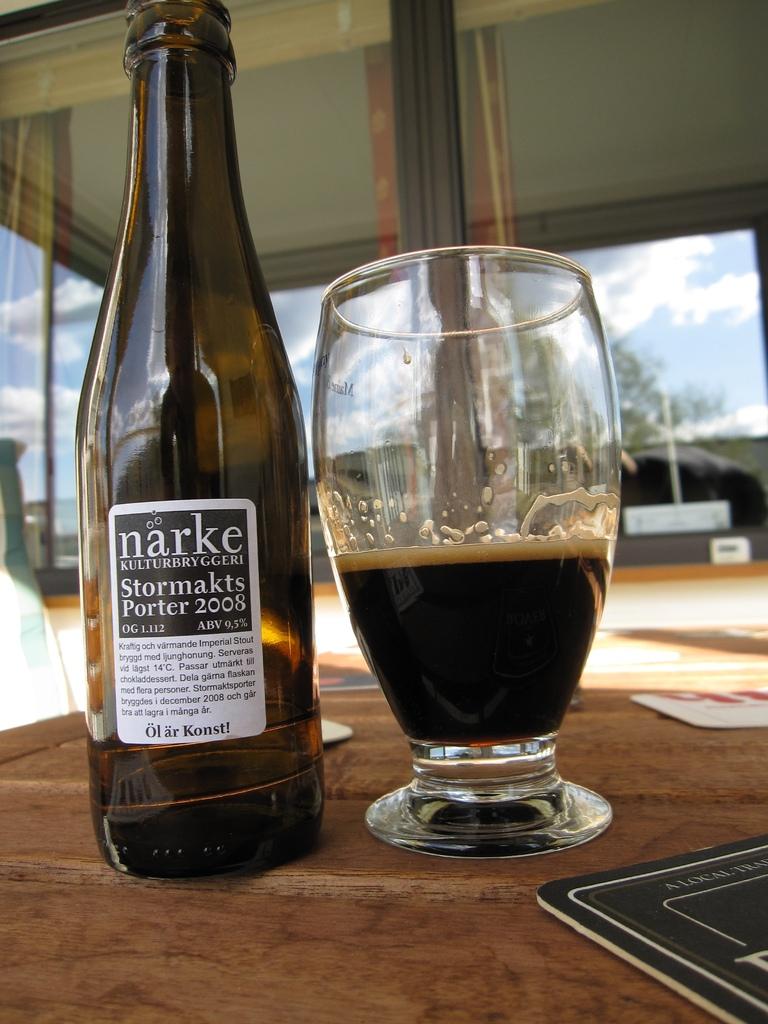What ind of beer is this?
Your answer should be compact. Narke. What year was this beer made?
Provide a short and direct response. 2008. 